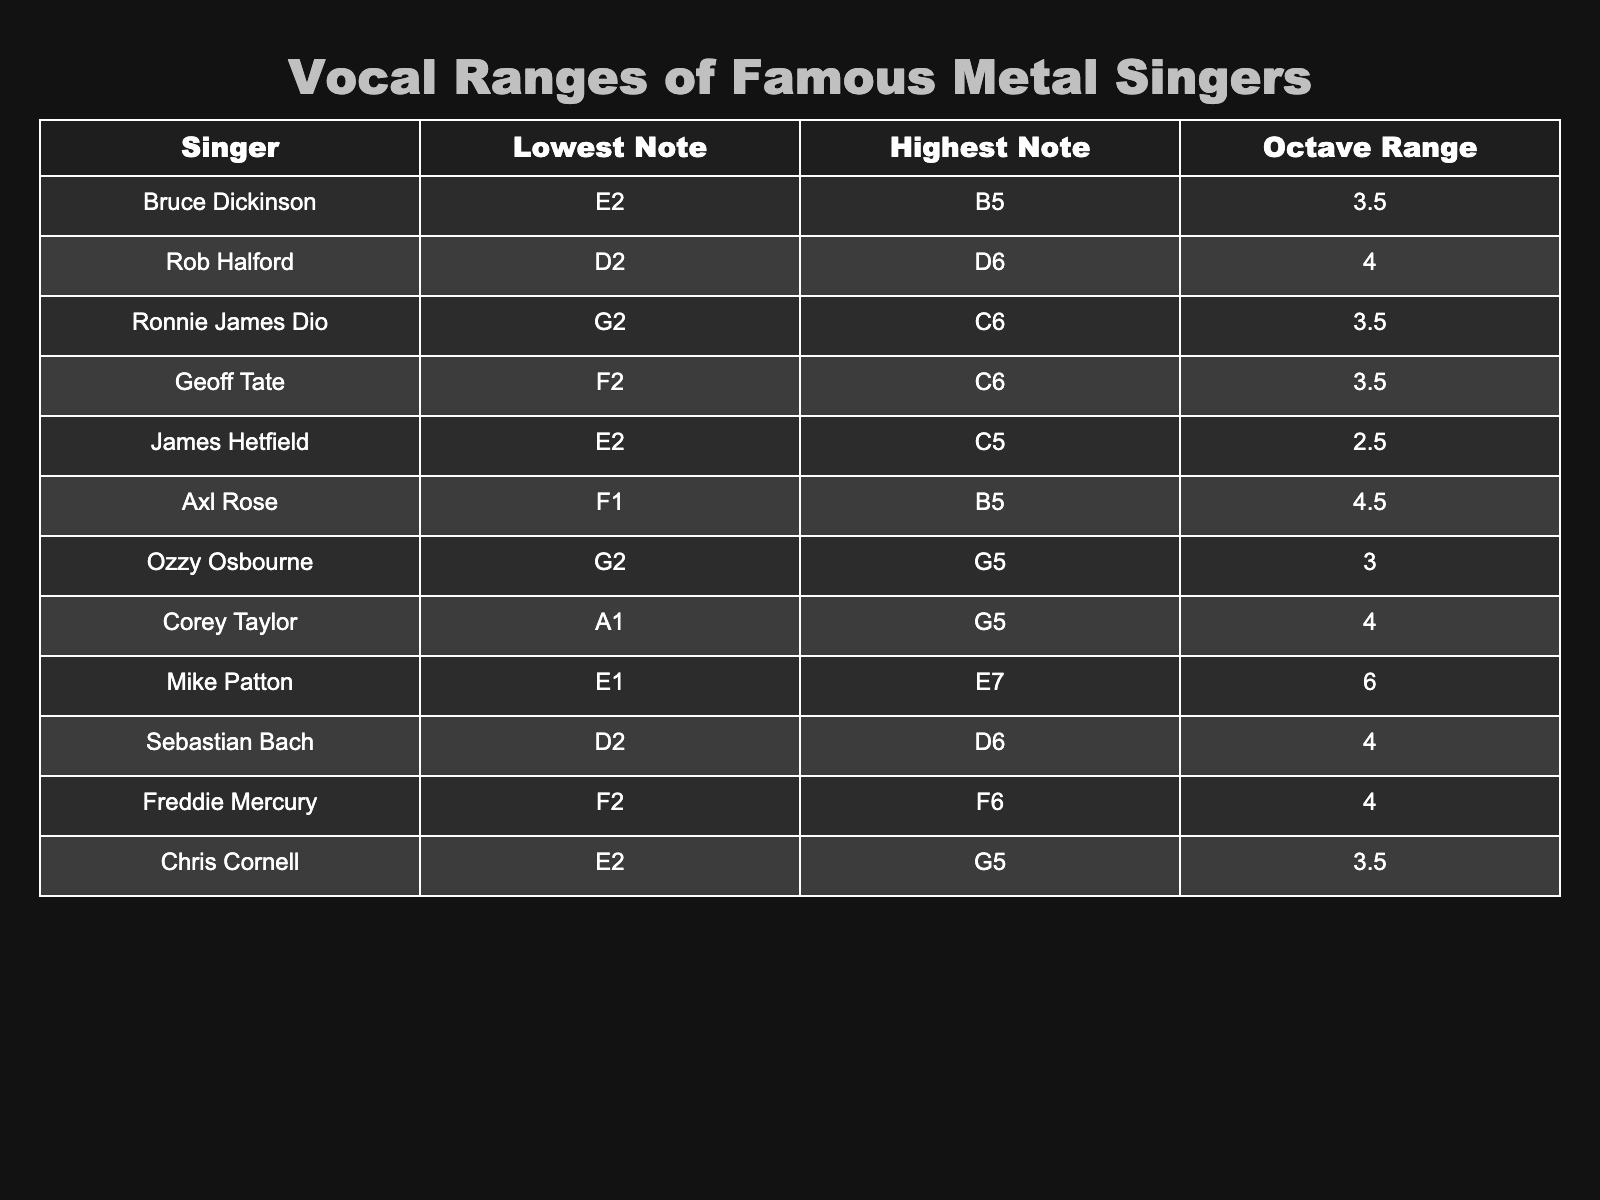What is the highest note reached by Bruce Dickinson? According to the table, Bruce Dickinson's highest note is B5. You can find this information in the "Highest Note" column next to his name in the "Singer" column.
Answer: B5 Which singer has the widest vocal range? Mike Patton has the widest range with 6 octaves (E1 to E7). This can be determined by checking the "Octave Range" column and identifying the maximum value for octave ranges.
Answer: 6 octaves Is Axl Rose’s lowest note higher than that of Chris Cornell? Axl Rose has a lowest note of F1, while Chris Cornell's lowest note is E2. F1 is lower than E2, meaning Axl Rose's lowest note is not higher.
Answer: No What is the average octave range of all the singers listed? To find the average, add all the octave ranges: 3.5 + 4 + 3.5 + 3.5 + 2.5 + 4.5 + 3 + 4 + 6 + 4 + 4 + 3.5 = 46. The number of singers is 12, so the average is 46 / 12 = 3.83.
Answer: 3.83 Which singer can reach the highest note? Rob Halford can reach the highest note of D6, as indicated in the "Highest Note" column. You can identify this by scanning through all the highest notes listed.
Answer: D6 Who has the same octave range as Sebastian Bach? Both Bruce Dickinson and Sebastian Bach have an octave range of 4 octaves. You find this by checking the "Octave Range" column for each singer.
Answer: Bruce Dickinson Is Chris Cornell capable of hitting a note as high as Axl Rose? Axl Rose's highest note is B5, while Chris Cornell's highest note is G5. Since G5 is lower than B5, Chris Cornell cannot hit a note as high as Axl Rose.
Answer: No What is the difference in octave range between Corey Taylor and James Hetfield? Corey Taylor has an octave range of 4, while James Hetfield has 2.5. The difference is 4 - 2.5 = 1.5. This is calculated by subtracting the octave range of James Hetfield from that of Corey Taylor.
Answer: 1.5 